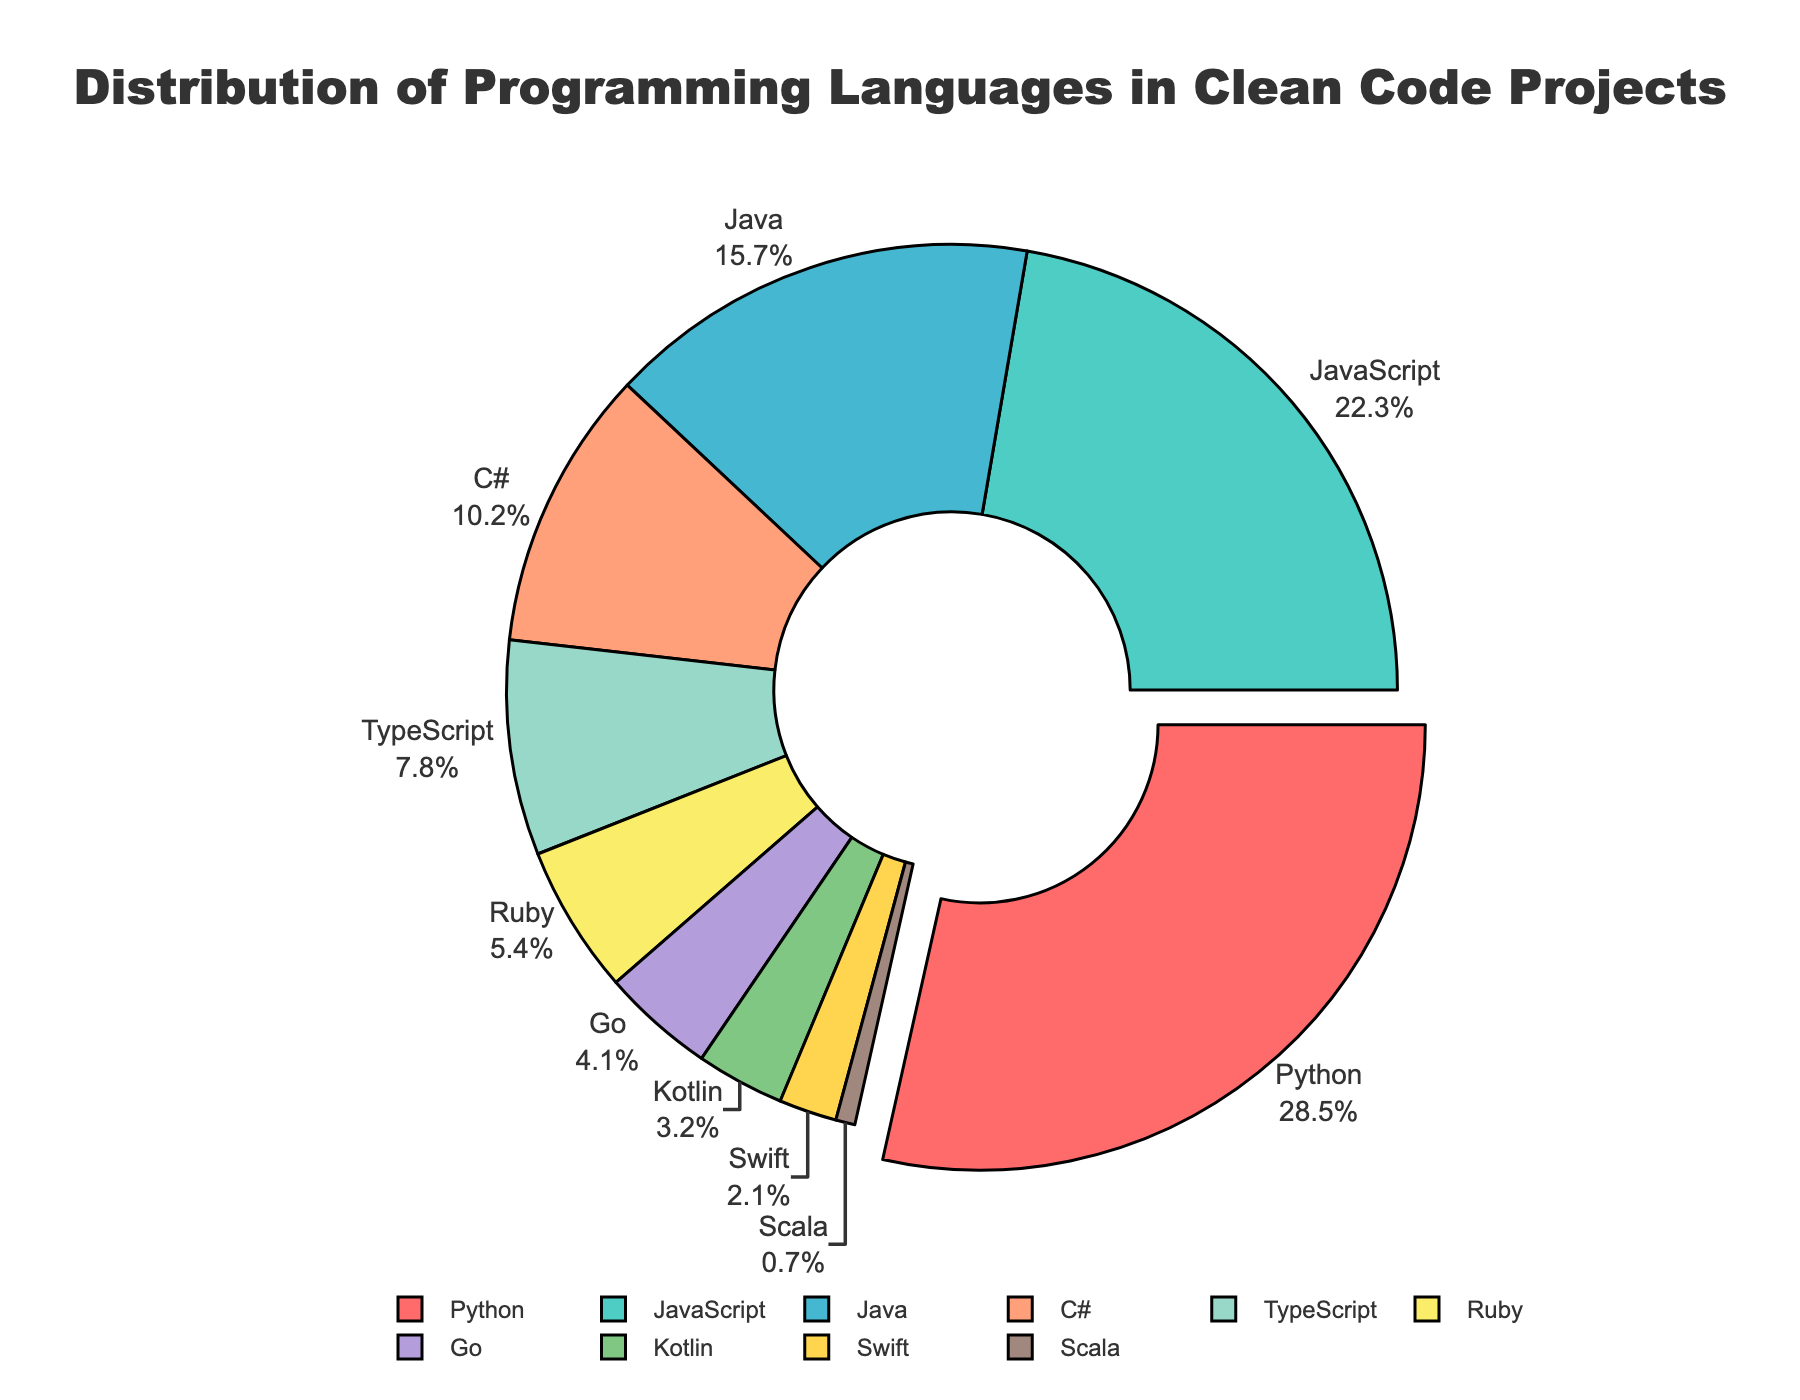What's the percentage of projects using Python? Look for the segment representing Python on the pie chart and read the percentage next to it.
Answer: 28.5% Which language is used the least in clean code projects? Identify the smallest segment of the pie chart and read the label next to it.
Answer: Scala Which two languages together make up approximately half of the projects? Add the percentages of the two largest segments: Python (28.5%) and JavaScript (22.3%). 28.5 + 22.3 = 50.8.
Answer: Python and JavaScript How does the use of Java compare to C# in clean code projects? Look at the segments for Java and C#. Java has 15.7% and C# has 10.2%. Java is used more.
Answer: Java is used more than C# What is the combined percentage of projects using TypeScript, Ruby, and Go? Sum the percentages of TypeScript (7.8%), Ruby (5.4%), and Go (4.1%). 7.8 + 5.4 + 4.1 = 17.3%.
Answer: 17.3% What color represents the language with the highest percentage? The language with the highest percentage is Python, which is marked in red.
Answer: Red What is the difference in percentage between JavaScript and Swift? Subtract the percentage of Swift (2.1%) from JavaScript's percentage (22.3%). 22.3 - 2.1 = 20.2.
Answer: 20.2% Is Kotlin used more than Ruby? Compare the percentages of Kotlin (3.2%) and Ruby (5.4%). Ruby has a higher percentage.
Answer: No What percentage of projects use languages other than Python, JavaScript, and Java? Subtract the sum of the percentages for Python (28.5%), JavaScript (22.3%), and Java (15.7%) from 100%. 28.5 + 22.3 + 15.7 = 66.5, then 100 - 66.5 = 33.5.
Answer: 33.5% Which languages are represented in shades of blue-green? Look at the legend or chart to identify segments shaded in blue-green colors: JavaScript (teal) and Swift (light blue).
Answer: JavaScript and Swift 